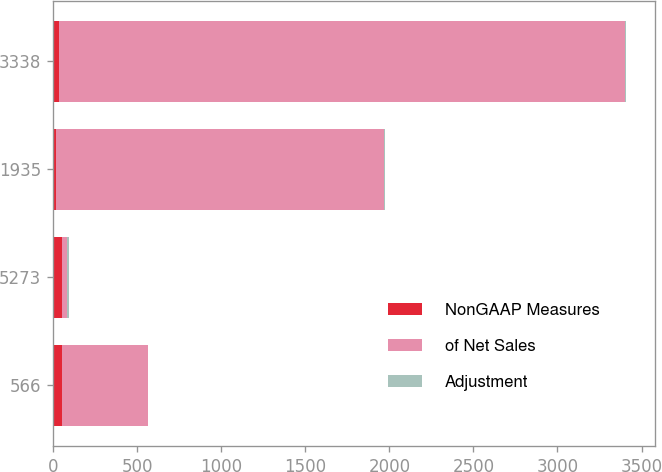<chart> <loc_0><loc_0><loc_500><loc_500><stacked_bar_chart><ecel><fcel>566<fcel>5273<fcel>1935<fcel>3338<nl><fcel>NonGAAP Measures<fcel>51<fcel>51<fcel>18<fcel>33<nl><fcel>of Net Sales<fcel>515<fcel>33<fcel>1953<fcel>3371<nl><fcel>Adjustment<fcel>0.8<fcel>7.8<fcel>2.9<fcel>5<nl></chart> 